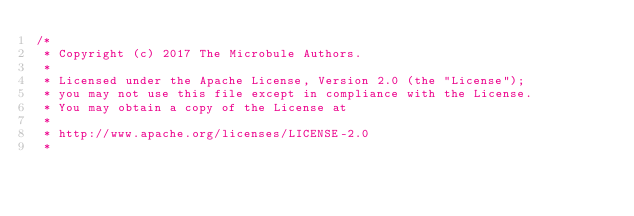Convert code to text. <code><loc_0><loc_0><loc_500><loc_500><_Java_>/*
 * Copyright (c) 2017 The Microbule Authors.
 *
 * Licensed under the Apache License, Version 2.0 (the "License");
 * you may not use this file except in compliance with the License.
 * You may obtain a copy of the License at
 *
 * http://www.apache.org/licenses/LICENSE-2.0
 *</code> 